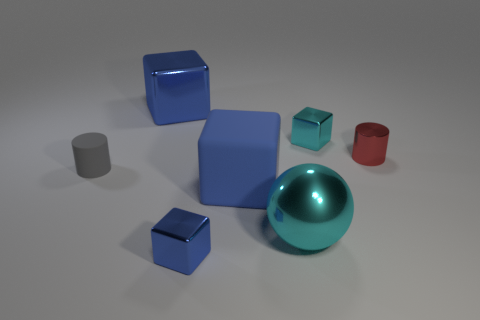What is the size of the metal thing that is the same color as the large metal ball?
Make the answer very short. Small. There is a small shiny object that is the same color as the large metal ball; what is its shape?
Give a very brief answer. Cube. Is there a red metallic cylinder that is behind the red thing to the right of the matte block?
Offer a terse response. No. What is the material of the cyan object that is in front of the gray cylinder?
Offer a very short reply. Metal. Is the red thing the same shape as the big cyan object?
Offer a very short reply. No. The tiny cylinder that is left of the tiny cylinder to the right of the big metal thing that is behind the large blue rubber cube is what color?
Your answer should be compact. Gray. How many small blue things are the same shape as the small red metallic object?
Make the answer very short. 0. How big is the cyan metallic ball on the right side of the gray matte thing in front of the tiny shiny cylinder?
Provide a succinct answer. Large. Is the matte cylinder the same size as the blue matte block?
Your answer should be very brief. No. There is a rubber object left of the small thing in front of the cyan sphere; is there a cylinder in front of it?
Keep it short and to the point. No. 